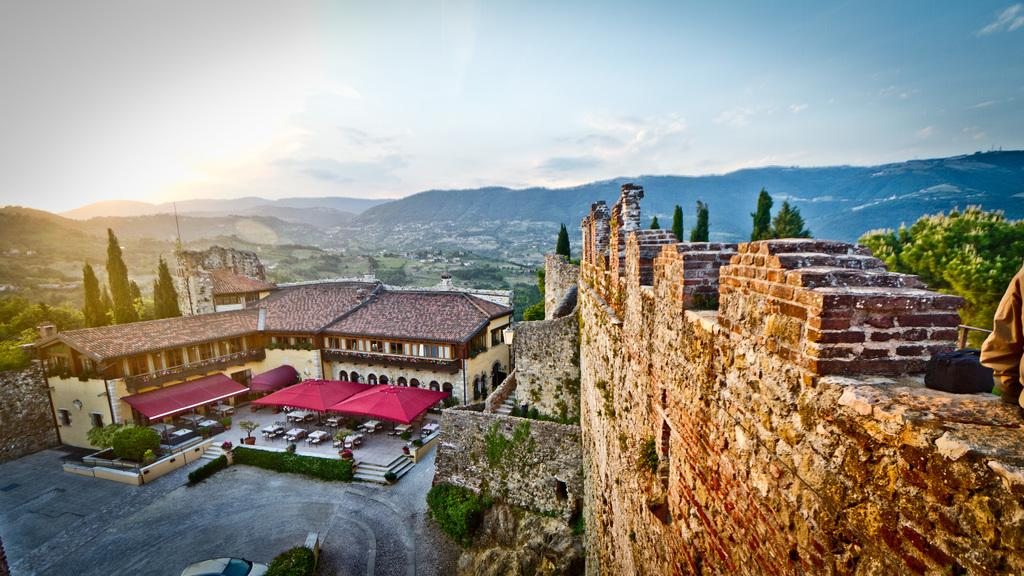What type of structures can be seen in the image? There are buildings in the image. What type of vegetation is present in the image? There are trees and plants in the image. What type of furniture is visible in the image? There are tables and chairs in the image. What is visible in the sky in the image? There are clouds in the image, and the sky is visible. What mode of transportation is present in the image? There is a car in the image. What is the black object in the image? The black object in the image is not specified, but it could be a car, a building, or another object. Can you tell me how many apples are on the table in the image? There is no mention of apples or any fruit in the image. How does the car pay its taxes in the image? There is no indication of taxation or payment in the image. 